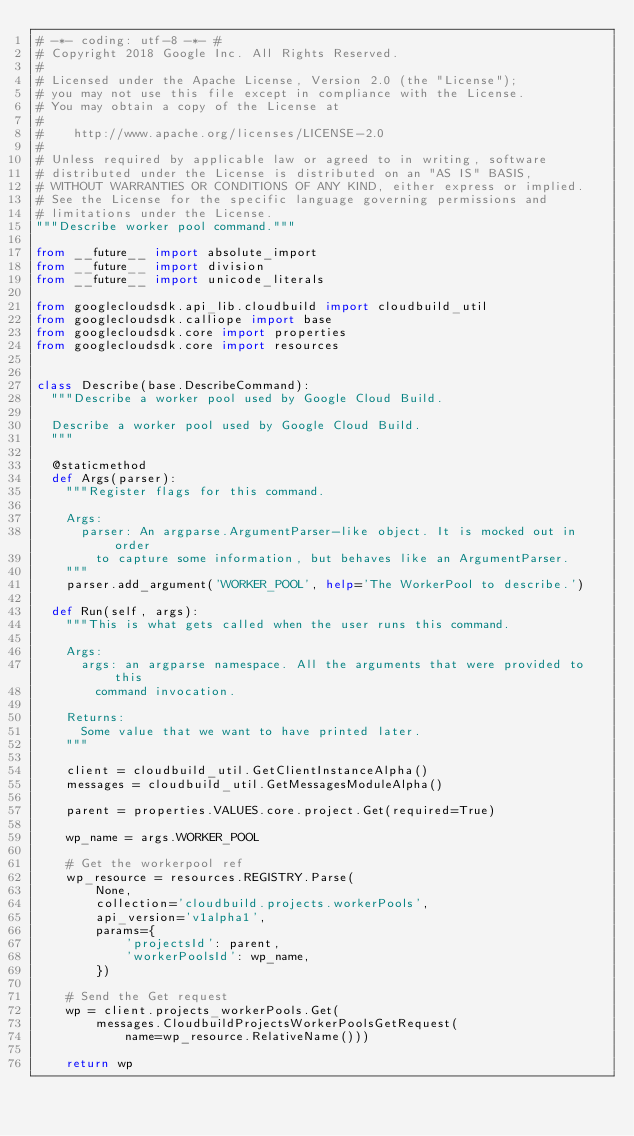Convert code to text. <code><loc_0><loc_0><loc_500><loc_500><_Python_># -*- coding: utf-8 -*- #
# Copyright 2018 Google Inc. All Rights Reserved.
#
# Licensed under the Apache License, Version 2.0 (the "License");
# you may not use this file except in compliance with the License.
# You may obtain a copy of the License at
#
#    http://www.apache.org/licenses/LICENSE-2.0
#
# Unless required by applicable law or agreed to in writing, software
# distributed under the License is distributed on an "AS IS" BASIS,
# WITHOUT WARRANTIES OR CONDITIONS OF ANY KIND, either express or implied.
# See the License for the specific language governing permissions and
# limitations under the License.
"""Describe worker pool command."""

from __future__ import absolute_import
from __future__ import division
from __future__ import unicode_literals

from googlecloudsdk.api_lib.cloudbuild import cloudbuild_util
from googlecloudsdk.calliope import base
from googlecloudsdk.core import properties
from googlecloudsdk.core import resources


class Describe(base.DescribeCommand):
  """Describe a worker pool used by Google Cloud Build.

  Describe a worker pool used by Google Cloud Build.
  """

  @staticmethod
  def Args(parser):
    """Register flags for this command.

    Args:
      parser: An argparse.ArgumentParser-like object. It is mocked out in order
        to capture some information, but behaves like an ArgumentParser.
    """
    parser.add_argument('WORKER_POOL', help='The WorkerPool to describe.')

  def Run(self, args):
    """This is what gets called when the user runs this command.

    Args:
      args: an argparse namespace. All the arguments that were provided to this
        command invocation.

    Returns:
      Some value that we want to have printed later.
    """

    client = cloudbuild_util.GetClientInstanceAlpha()
    messages = cloudbuild_util.GetMessagesModuleAlpha()

    parent = properties.VALUES.core.project.Get(required=True)

    wp_name = args.WORKER_POOL

    # Get the workerpool ref
    wp_resource = resources.REGISTRY.Parse(
        None,
        collection='cloudbuild.projects.workerPools',
        api_version='v1alpha1',
        params={
            'projectsId': parent,
            'workerPoolsId': wp_name,
        })

    # Send the Get request
    wp = client.projects_workerPools.Get(
        messages.CloudbuildProjectsWorkerPoolsGetRequest(
            name=wp_resource.RelativeName()))

    return wp
</code> 